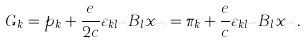Convert formula to latex. <formula><loc_0><loc_0><loc_500><loc_500>G _ { k } = p _ { k } + \frac { e } { 2 c } \varepsilon _ { k l m } B _ { l } x _ { m } = \pi _ { k } + \frac { e } { c } \varepsilon _ { k l m } B _ { l } x _ { m } .</formula> 